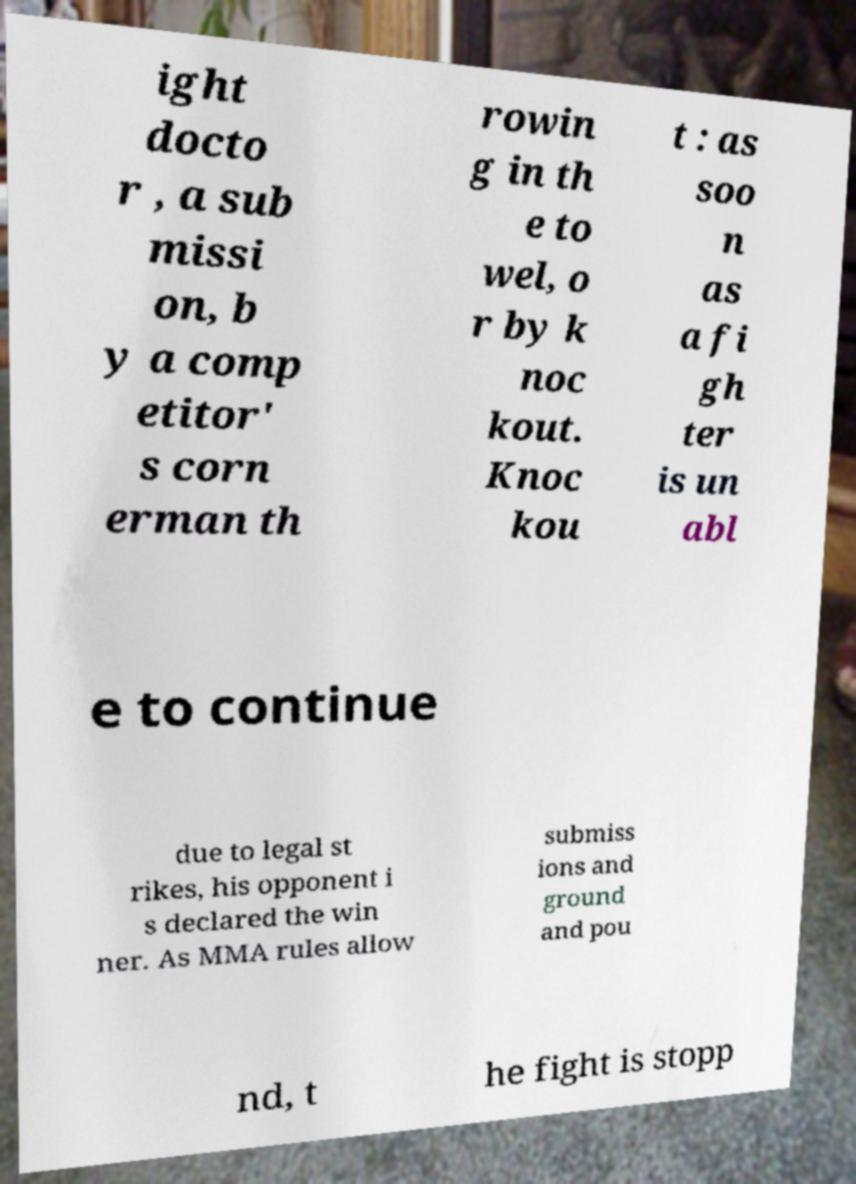Please read and relay the text visible in this image. What does it say? ight docto r , a sub missi on, b y a comp etitor' s corn erman th rowin g in th e to wel, o r by k noc kout. Knoc kou t : as soo n as a fi gh ter is un abl e to continue due to legal st rikes, his opponent i s declared the win ner. As MMA rules allow submiss ions and ground and pou nd, t he fight is stopp 